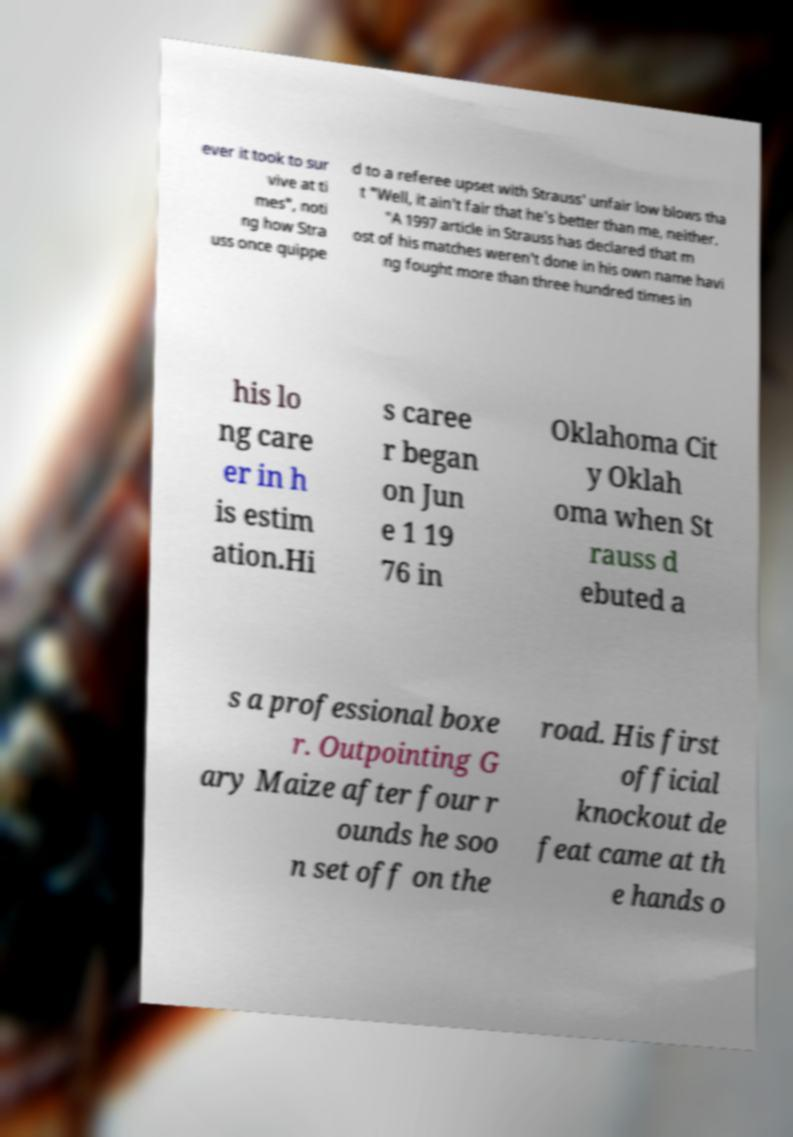I need the written content from this picture converted into text. Can you do that? ever it took to sur vive at ti mes", noti ng how Stra uss once quippe d to a referee upset with Strauss' unfair low blows tha t "Well, it ain't fair that he's better than me, neither. "A 1997 article in Strauss has declared that m ost of his matches weren't done in his own name havi ng fought more than three hundred times in his lo ng care er in h is estim ation.Hi s caree r began on Jun e 1 19 76 in Oklahoma Cit y Oklah oma when St rauss d ebuted a s a professional boxe r. Outpointing G ary Maize after four r ounds he soo n set off on the road. His first official knockout de feat came at th e hands o 